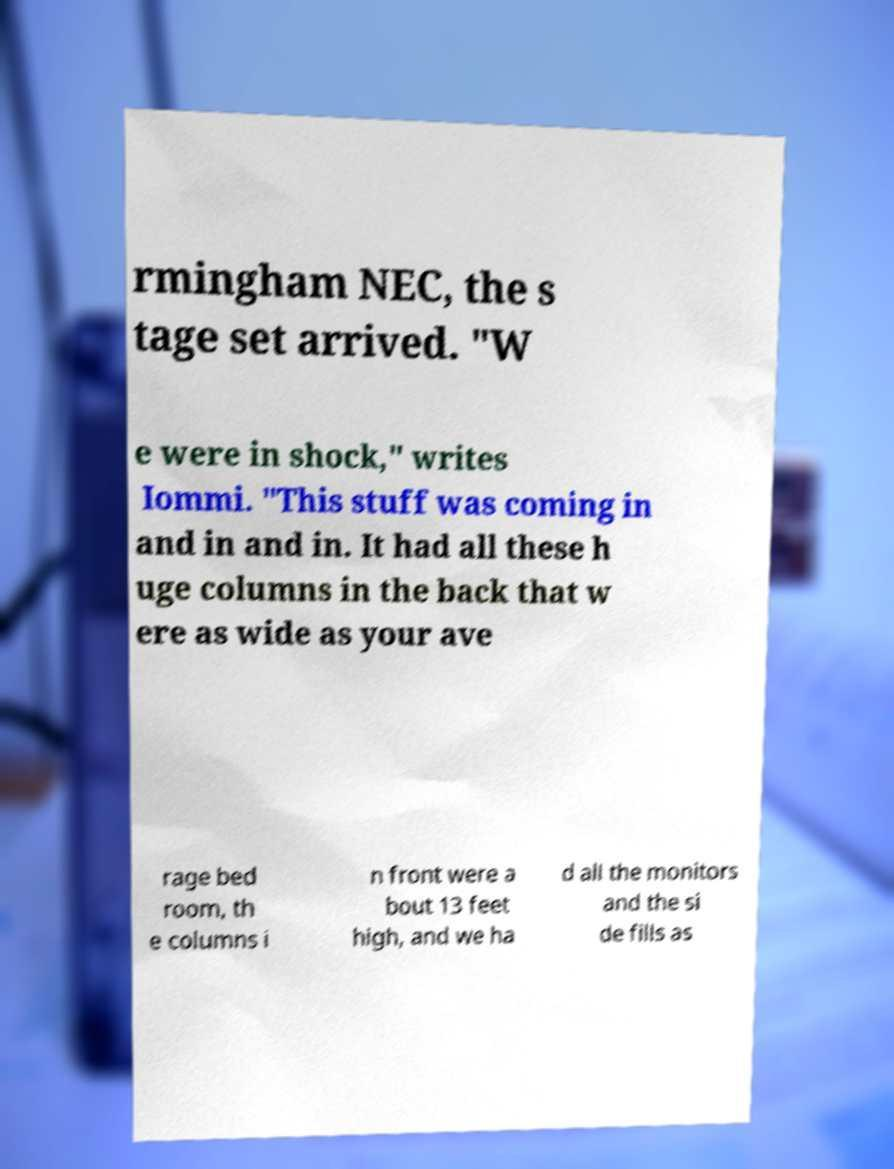What messages or text are displayed in this image? I need them in a readable, typed format. rmingham NEC, the s tage set arrived. "W e were in shock," writes Iommi. "This stuff was coming in and in and in. It had all these h uge columns in the back that w ere as wide as your ave rage bed room, th e columns i n front were a bout 13 feet high, and we ha d all the monitors and the si de fills as 